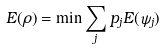<formula> <loc_0><loc_0><loc_500><loc_500>E ( \rho ) = \min \sum _ { j } p _ { j } E ( \psi _ { j } )</formula> 